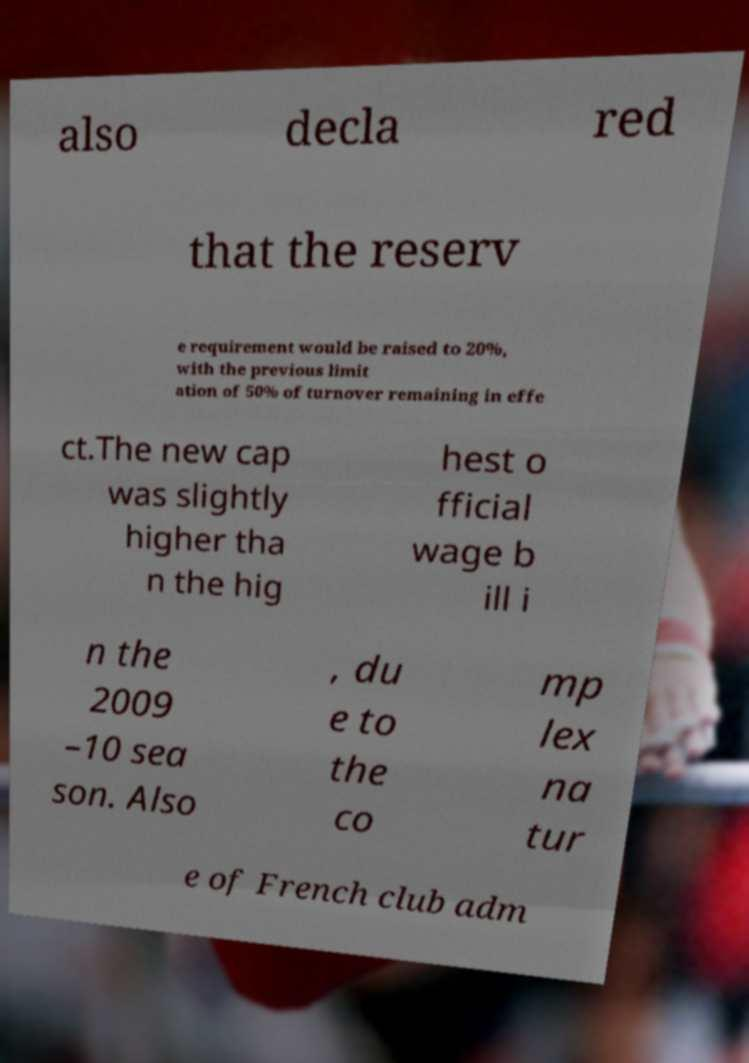Can you read and provide the text displayed in the image?This photo seems to have some interesting text. Can you extract and type it out for me? also decla red that the reserv e requirement would be raised to 20%, with the previous limit ation of 50% of turnover remaining in effe ct.The new cap was slightly higher tha n the hig hest o fficial wage b ill i n the 2009 –10 sea son. Also , du e to the co mp lex na tur e of French club adm 